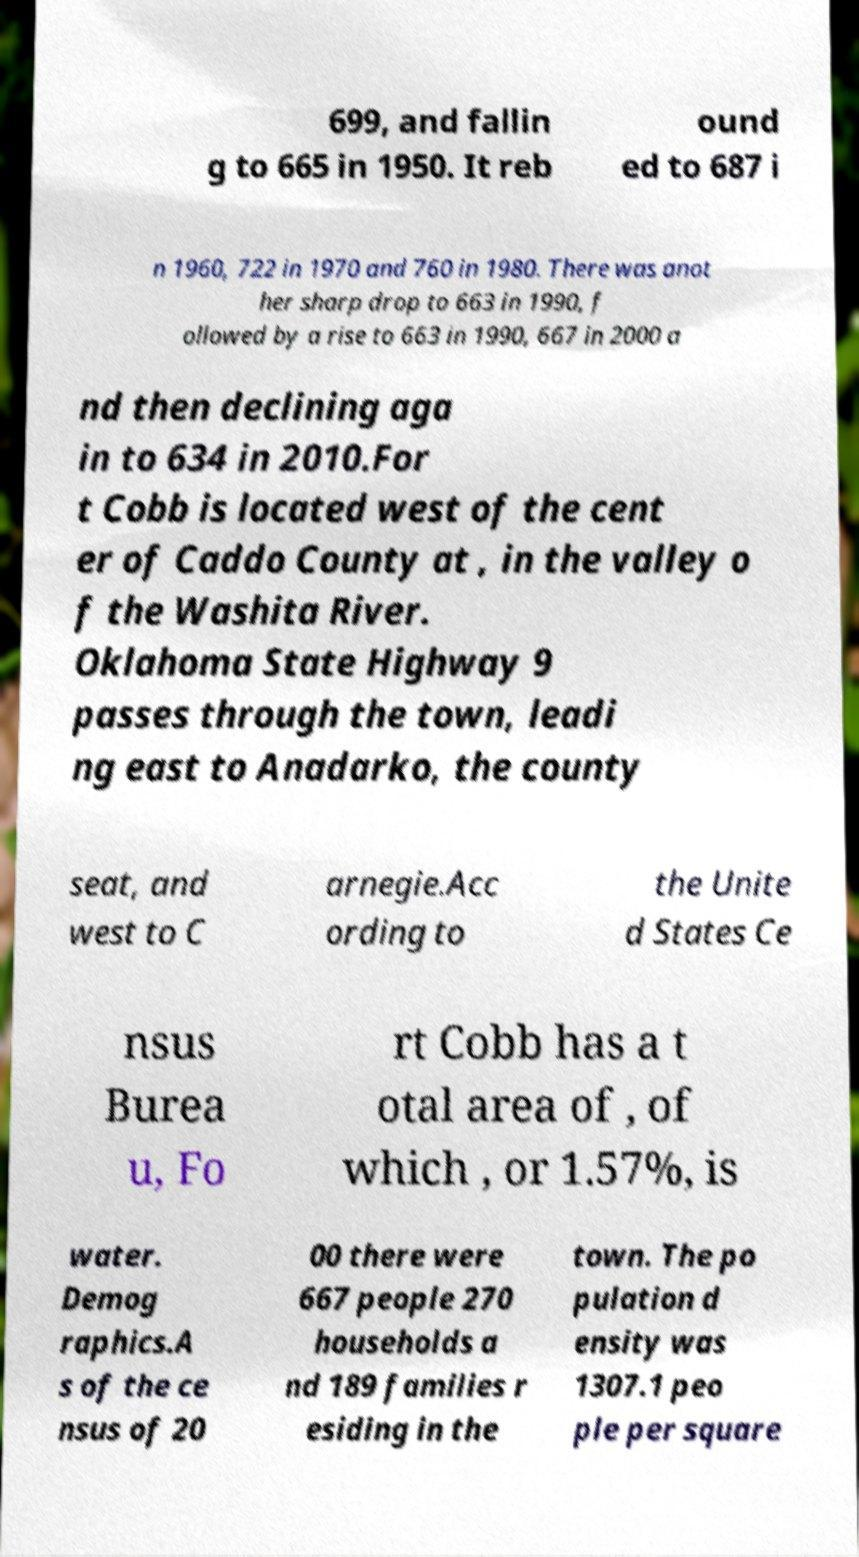Please identify and transcribe the text found in this image. 699, and fallin g to 665 in 1950. It reb ound ed to 687 i n 1960, 722 in 1970 and 760 in 1980. There was anot her sharp drop to 663 in 1990, f ollowed by a rise to 663 in 1990, 667 in 2000 a nd then declining aga in to 634 in 2010.For t Cobb is located west of the cent er of Caddo County at , in the valley o f the Washita River. Oklahoma State Highway 9 passes through the town, leadi ng east to Anadarko, the county seat, and west to C arnegie.Acc ording to the Unite d States Ce nsus Burea u, Fo rt Cobb has a t otal area of , of which , or 1.57%, is water. Demog raphics.A s of the ce nsus of 20 00 there were 667 people 270 households a nd 189 families r esiding in the town. The po pulation d ensity was 1307.1 peo ple per square 